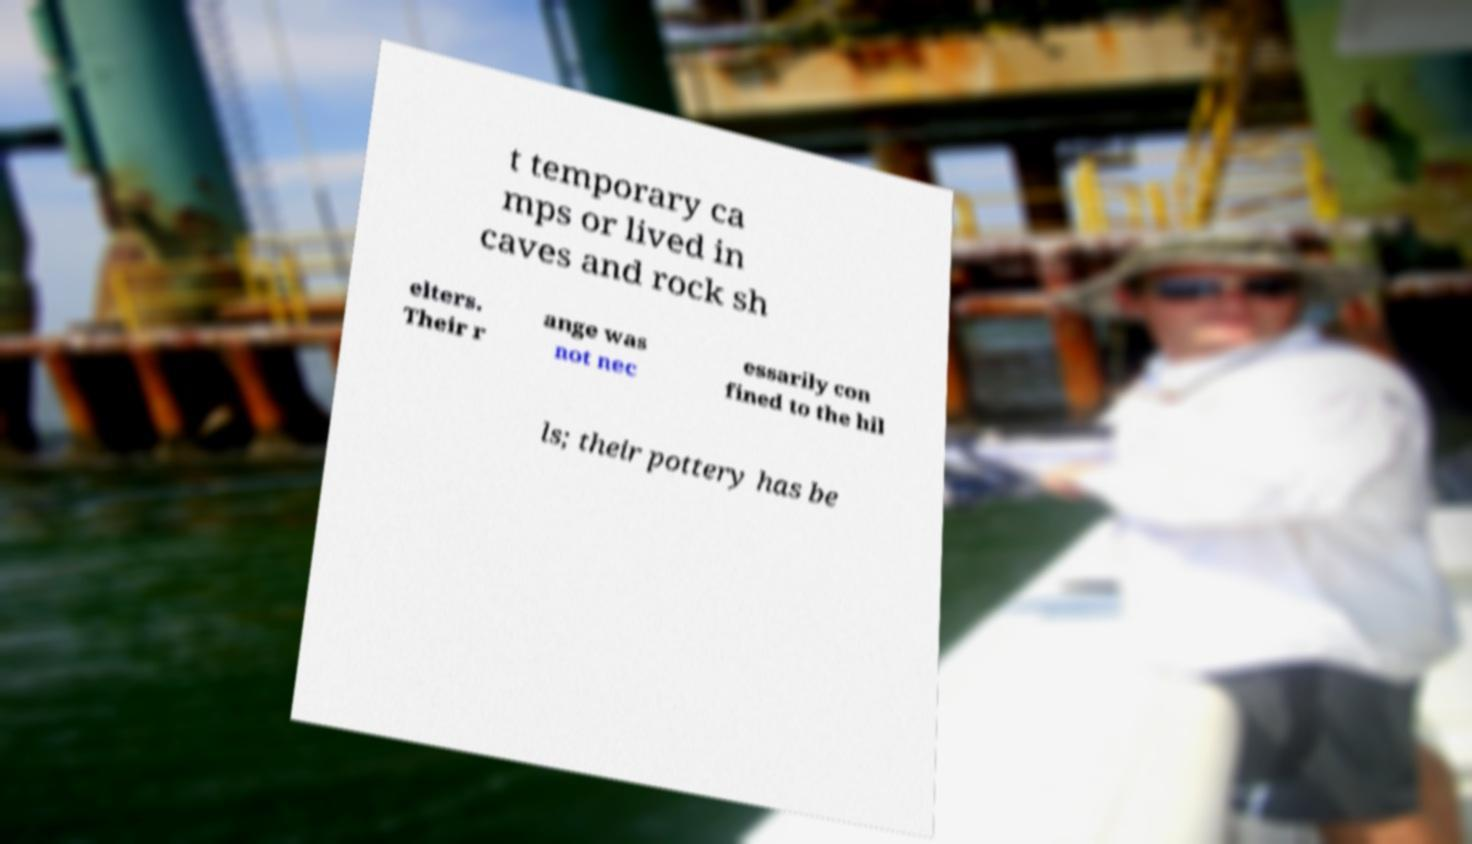Could you extract and type out the text from this image? t temporary ca mps or lived in caves and rock sh elters. Their r ange was not nec essarily con fined to the hil ls; their pottery has be 